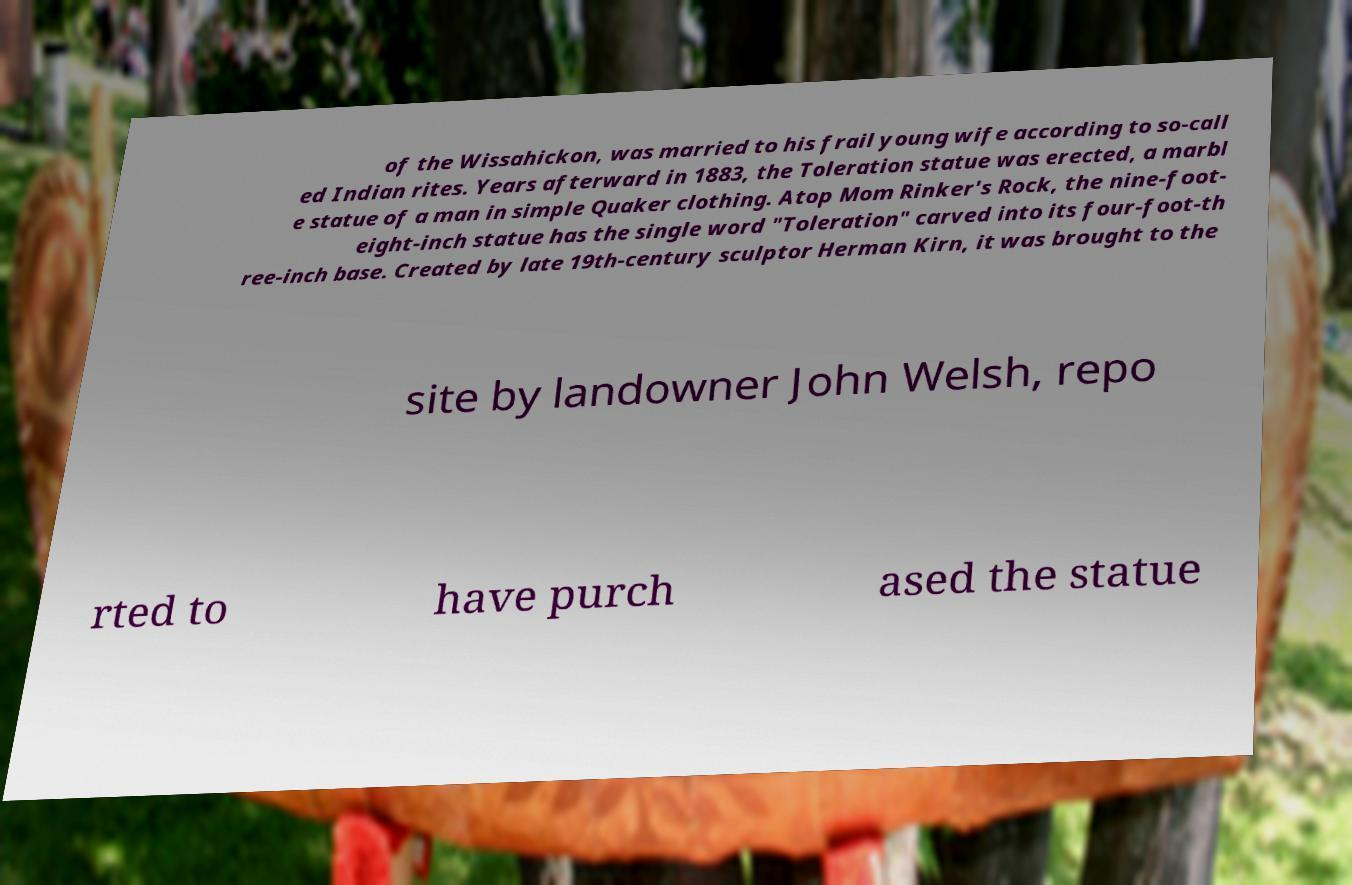I need the written content from this picture converted into text. Can you do that? of the Wissahickon, was married to his frail young wife according to so-call ed Indian rites. Years afterward in 1883, the Toleration statue was erected, a marbl e statue of a man in simple Quaker clothing. Atop Mom Rinker's Rock, the nine-foot- eight-inch statue has the single word "Toleration" carved into its four-foot-th ree-inch base. Created by late 19th-century sculptor Herman Kirn, it was brought to the site by landowner John Welsh, repo rted to have purch ased the statue 